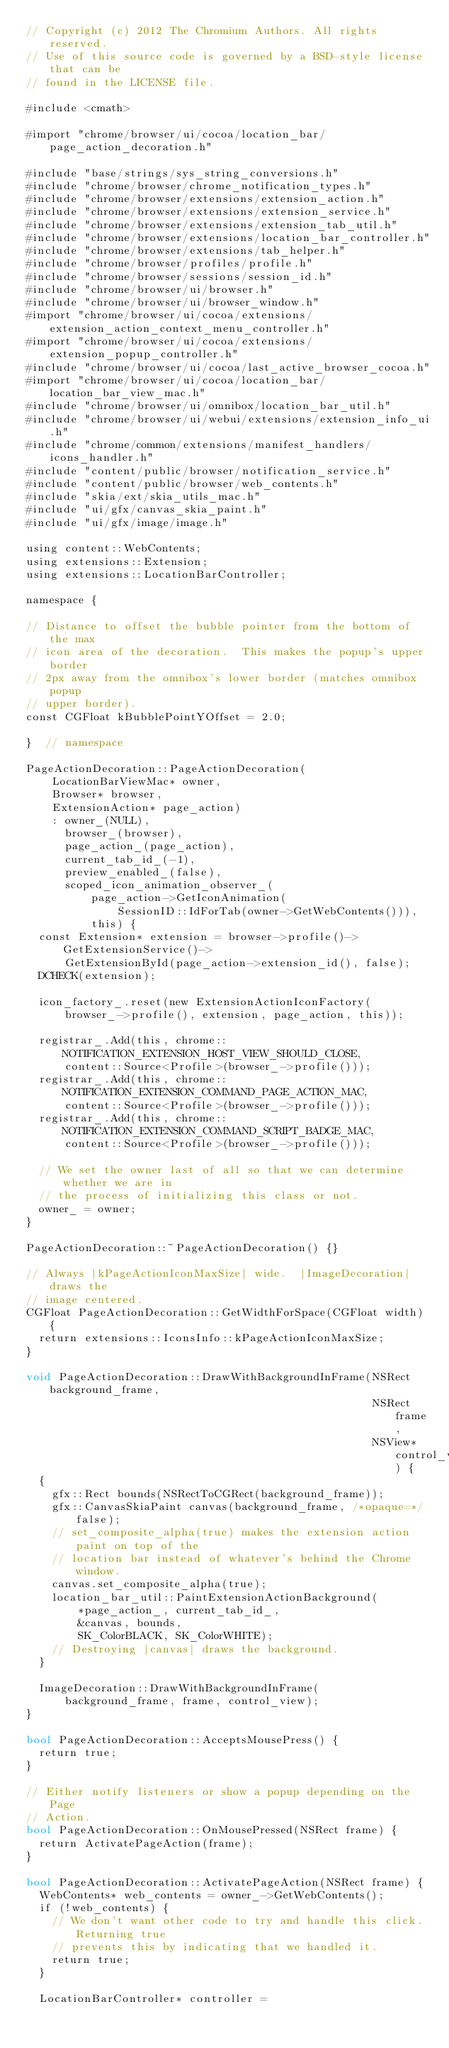Convert code to text. <code><loc_0><loc_0><loc_500><loc_500><_ObjectiveC_>// Copyright (c) 2012 The Chromium Authors. All rights reserved.
// Use of this source code is governed by a BSD-style license that can be
// found in the LICENSE file.

#include <cmath>

#import "chrome/browser/ui/cocoa/location_bar/page_action_decoration.h"

#include "base/strings/sys_string_conversions.h"
#include "chrome/browser/chrome_notification_types.h"
#include "chrome/browser/extensions/extension_action.h"
#include "chrome/browser/extensions/extension_service.h"
#include "chrome/browser/extensions/extension_tab_util.h"
#include "chrome/browser/extensions/location_bar_controller.h"
#include "chrome/browser/extensions/tab_helper.h"
#include "chrome/browser/profiles/profile.h"
#include "chrome/browser/sessions/session_id.h"
#include "chrome/browser/ui/browser.h"
#include "chrome/browser/ui/browser_window.h"
#import "chrome/browser/ui/cocoa/extensions/extension_action_context_menu_controller.h"
#import "chrome/browser/ui/cocoa/extensions/extension_popup_controller.h"
#include "chrome/browser/ui/cocoa/last_active_browser_cocoa.h"
#import "chrome/browser/ui/cocoa/location_bar/location_bar_view_mac.h"
#include "chrome/browser/ui/omnibox/location_bar_util.h"
#include "chrome/browser/ui/webui/extensions/extension_info_ui.h"
#include "chrome/common/extensions/manifest_handlers/icons_handler.h"
#include "content/public/browser/notification_service.h"
#include "content/public/browser/web_contents.h"
#include "skia/ext/skia_utils_mac.h"
#include "ui/gfx/canvas_skia_paint.h"
#include "ui/gfx/image/image.h"

using content::WebContents;
using extensions::Extension;
using extensions::LocationBarController;

namespace {

// Distance to offset the bubble pointer from the bottom of the max
// icon area of the decoration.  This makes the popup's upper border
// 2px away from the omnibox's lower border (matches omnibox popup
// upper border).
const CGFloat kBubblePointYOffset = 2.0;

}  // namespace

PageActionDecoration::PageActionDecoration(
    LocationBarViewMac* owner,
    Browser* browser,
    ExtensionAction* page_action)
    : owner_(NULL),
      browser_(browser),
      page_action_(page_action),
      current_tab_id_(-1),
      preview_enabled_(false),
      scoped_icon_animation_observer_(
          page_action->GetIconAnimation(
              SessionID::IdForTab(owner->GetWebContents())),
          this) {
  const Extension* extension = browser->profile()->GetExtensionService()->
      GetExtensionById(page_action->extension_id(), false);
  DCHECK(extension);

  icon_factory_.reset(new ExtensionActionIconFactory(
      browser_->profile(), extension, page_action, this));

  registrar_.Add(this, chrome::NOTIFICATION_EXTENSION_HOST_VIEW_SHOULD_CLOSE,
      content::Source<Profile>(browser_->profile()));
  registrar_.Add(this, chrome::NOTIFICATION_EXTENSION_COMMAND_PAGE_ACTION_MAC,
      content::Source<Profile>(browser_->profile()));
  registrar_.Add(this, chrome::NOTIFICATION_EXTENSION_COMMAND_SCRIPT_BADGE_MAC,
      content::Source<Profile>(browser_->profile()));

  // We set the owner last of all so that we can determine whether we are in
  // the process of initializing this class or not.
  owner_ = owner;
}

PageActionDecoration::~PageActionDecoration() {}

// Always |kPageActionIconMaxSize| wide.  |ImageDecoration| draws the
// image centered.
CGFloat PageActionDecoration::GetWidthForSpace(CGFloat width) {
  return extensions::IconsInfo::kPageActionIconMaxSize;
}

void PageActionDecoration::DrawWithBackgroundInFrame(NSRect background_frame,
                                                     NSRect frame,
                                                     NSView* control_view) {
  {
    gfx::Rect bounds(NSRectToCGRect(background_frame));
    gfx::CanvasSkiaPaint canvas(background_frame, /*opaque=*/false);
    // set_composite_alpha(true) makes the extension action paint on top of the
    // location bar instead of whatever's behind the Chrome window.
    canvas.set_composite_alpha(true);
    location_bar_util::PaintExtensionActionBackground(
        *page_action_, current_tab_id_,
        &canvas, bounds,
        SK_ColorBLACK, SK_ColorWHITE);
    // Destroying |canvas| draws the background.
  }

  ImageDecoration::DrawWithBackgroundInFrame(
      background_frame, frame, control_view);
}

bool PageActionDecoration::AcceptsMousePress() {
  return true;
}

// Either notify listeners or show a popup depending on the Page
// Action.
bool PageActionDecoration::OnMousePressed(NSRect frame) {
  return ActivatePageAction(frame);
}

bool PageActionDecoration::ActivatePageAction(NSRect frame) {
  WebContents* web_contents = owner_->GetWebContents();
  if (!web_contents) {
    // We don't want other code to try and handle this click. Returning true
    // prevents this by indicating that we handled it.
    return true;
  }

  LocationBarController* controller =</code> 